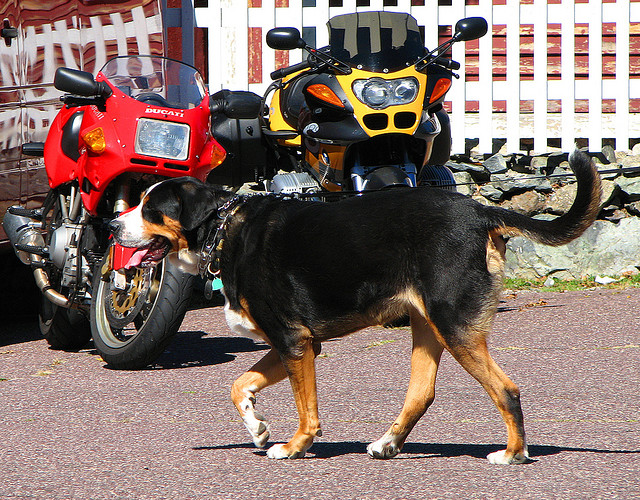Please transcribe the text information in this image. DUCATI 